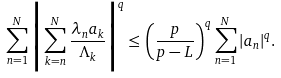<formula> <loc_0><loc_0><loc_500><loc_500>\sum ^ { N } _ { n = 1 } \Big { | } \sum ^ { N } _ { k = n } \frac { \lambda _ { n } a _ { k } } { \Lambda _ { k } } \Big { | } ^ { q } \leq \left ( \frac { p } { p - L } \right ) ^ { q } \sum ^ { N } _ { n = 1 } | a _ { n } | ^ { q } .</formula> 